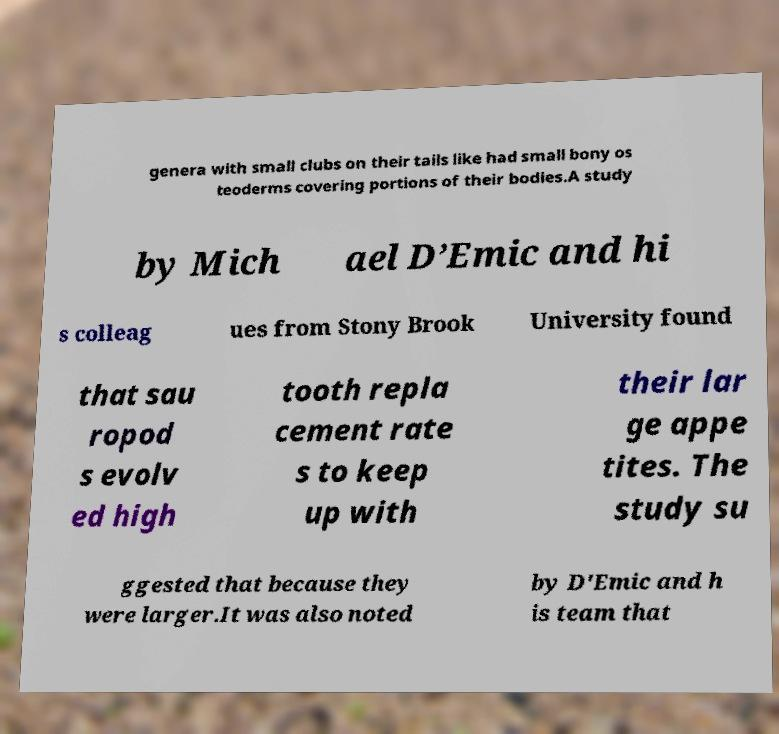Can you read and provide the text displayed in the image?This photo seems to have some interesting text. Can you extract and type it out for me? genera with small clubs on their tails like had small bony os teoderms covering portions of their bodies.A study by Mich ael D’Emic and hi s colleag ues from Stony Brook University found that sau ropod s evolv ed high tooth repla cement rate s to keep up with their lar ge appe tites. The study su ggested that because they were larger.It was also noted by D'Emic and h is team that 